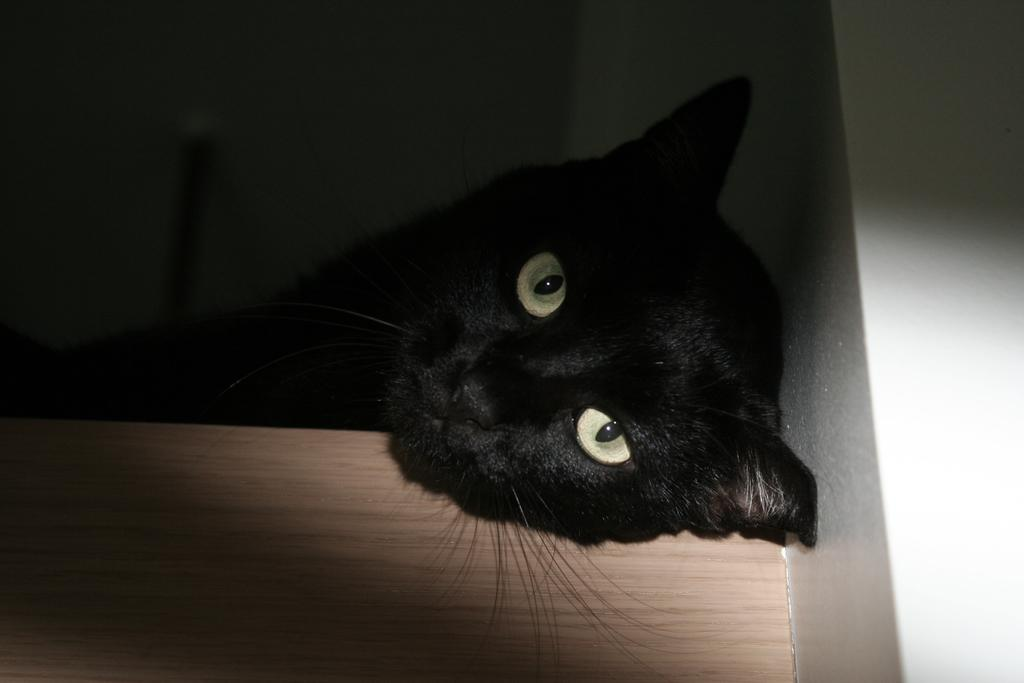What type of animal is in the image? There is a black cat in the image. What is the cat lying on? The cat is lying on a wooden surface. What can be seen in the background of the image? The background of the image is dark, and there is a wall visible. What type of vegetable is the cat holding in its paws in the image? There is no vegetable present in the image, and the cat is not holding anything in its paws. 